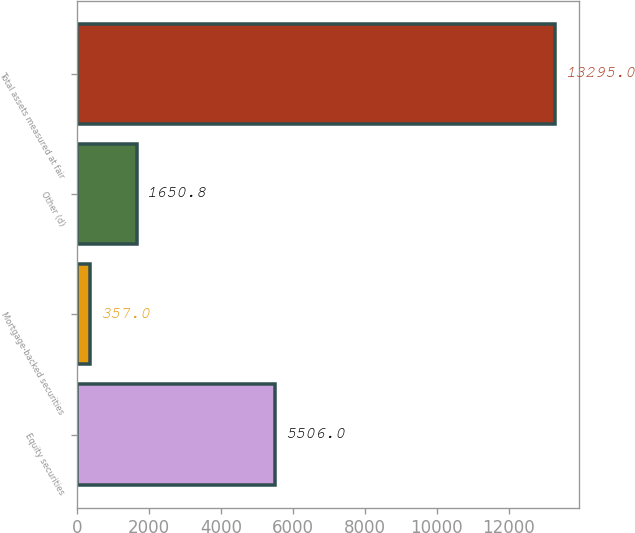Convert chart. <chart><loc_0><loc_0><loc_500><loc_500><bar_chart><fcel>Equity securities<fcel>Mortgage-backed securities<fcel>Other (d)<fcel>Total assets measured at fair<nl><fcel>5506<fcel>357<fcel>1650.8<fcel>13295<nl></chart> 